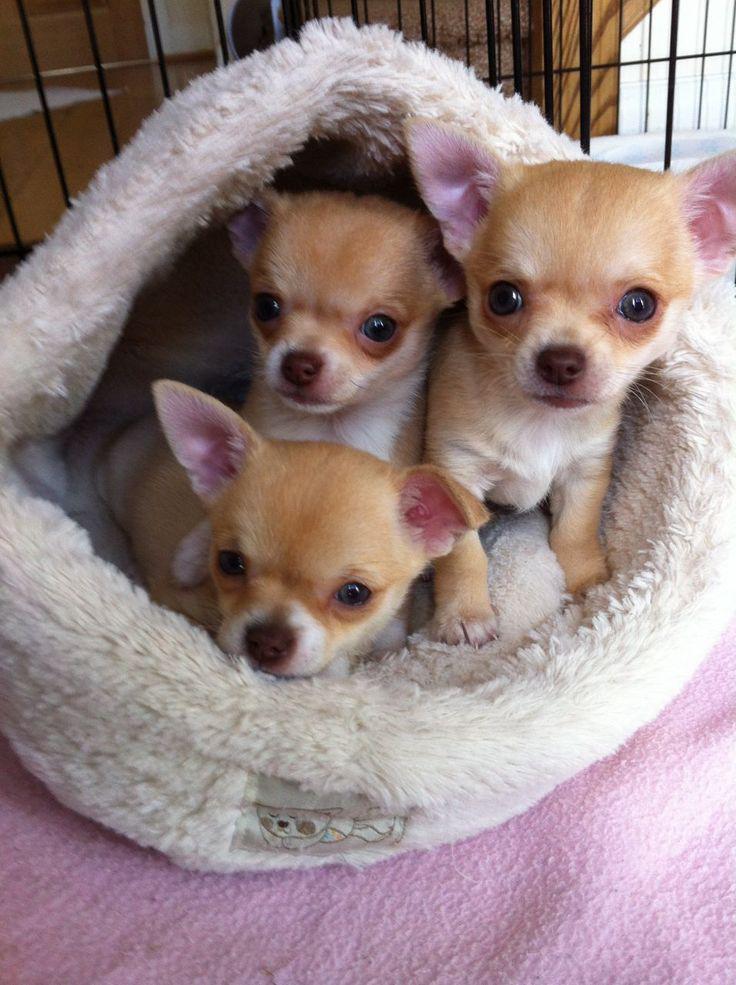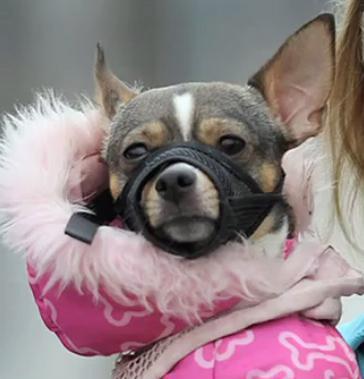The first image is the image on the left, the second image is the image on the right. For the images displayed, is the sentence "At least one dog is wearing a bowtie." factually correct? Answer yes or no. No. 